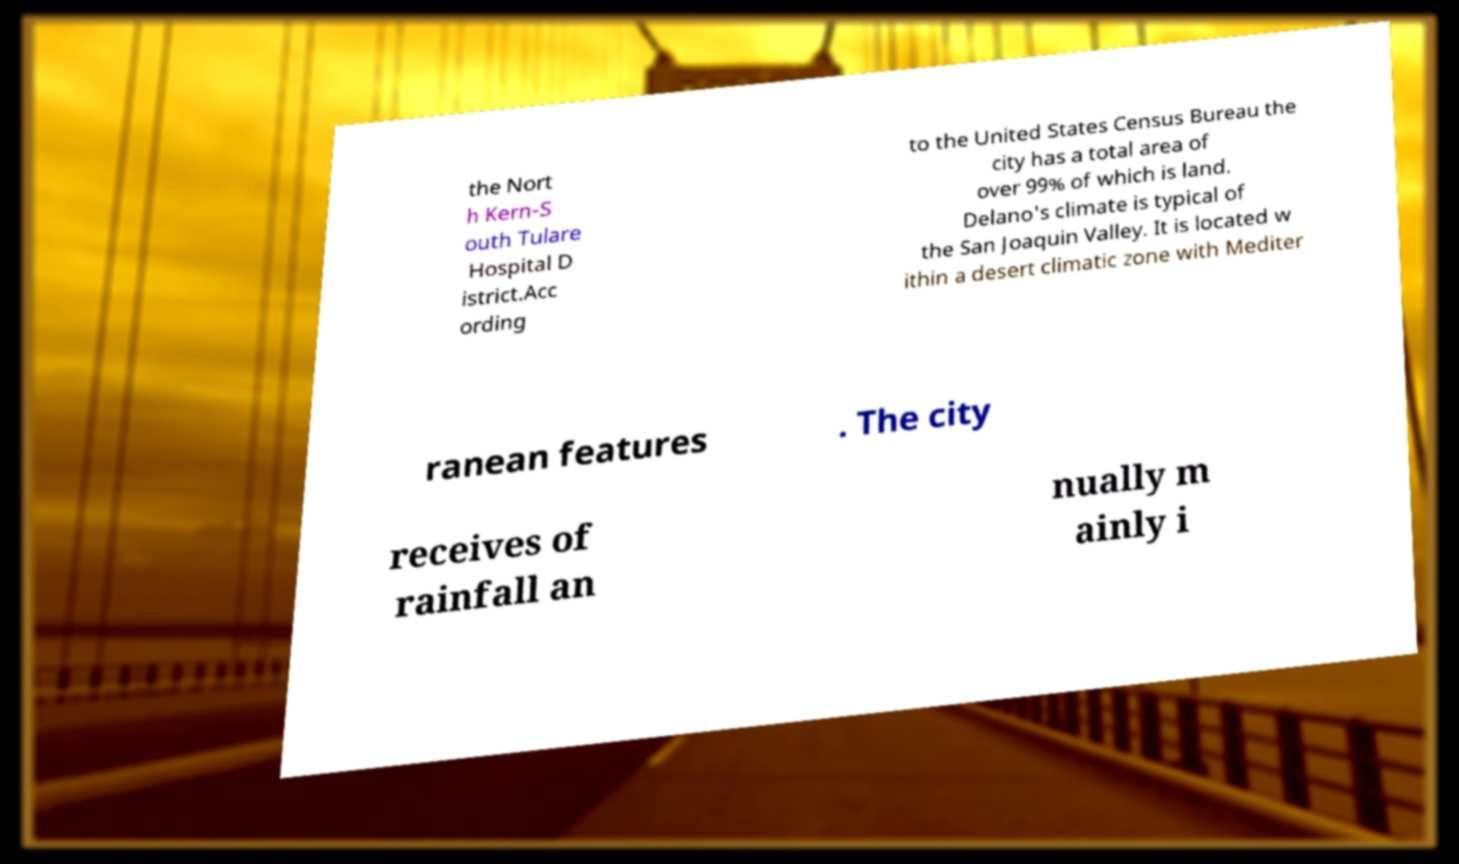What messages or text are displayed in this image? I need them in a readable, typed format. the Nort h Kern-S outh Tulare Hospital D istrict.Acc ording to the United States Census Bureau the city has a total area of over 99% of which is land. Delano's climate is typical of the San Joaquin Valley. It is located w ithin a desert climatic zone with Mediter ranean features . The city receives of rainfall an nually m ainly i 